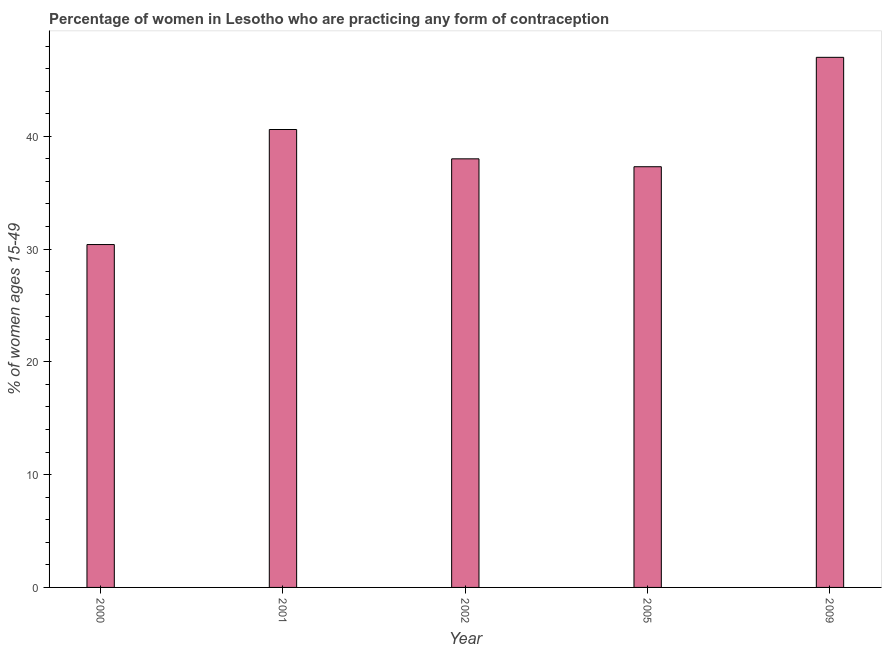What is the title of the graph?
Provide a succinct answer. Percentage of women in Lesotho who are practicing any form of contraception. What is the label or title of the X-axis?
Provide a short and direct response. Year. What is the label or title of the Y-axis?
Provide a short and direct response. % of women ages 15-49. What is the contraceptive prevalence in 2005?
Your response must be concise. 37.3. Across all years, what is the minimum contraceptive prevalence?
Offer a very short reply. 30.4. In which year was the contraceptive prevalence minimum?
Make the answer very short. 2000. What is the sum of the contraceptive prevalence?
Make the answer very short. 193.3. What is the difference between the contraceptive prevalence in 2002 and 2005?
Your answer should be very brief. 0.7. What is the average contraceptive prevalence per year?
Ensure brevity in your answer.  38.66. What is the median contraceptive prevalence?
Offer a terse response. 38. What is the ratio of the contraceptive prevalence in 2002 to that in 2009?
Make the answer very short. 0.81. What is the difference between the highest and the lowest contraceptive prevalence?
Your answer should be compact. 16.6. What is the % of women ages 15-49 in 2000?
Your answer should be compact. 30.4. What is the % of women ages 15-49 in 2001?
Offer a very short reply. 40.6. What is the % of women ages 15-49 of 2002?
Offer a terse response. 38. What is the % of women ages 15-49 of 2005?
Your answer should be very brief. 37.3. What is the % of women ages 15-49 in 2009?
Provide a short and direct response. 47. What is the difference between the % of women ages 15-49 in 2000 and 2001?
Provide a short and direct response. -10.2. What is the difference between the % of women ages 15-49 in 2000 and 2009?
Ensure brevity in your answer.  -16.6. What is the difference between the % of women ages 15-49 in 2001 and 2002?
Your answer should be compact. 2.6. What is the difference between the % of women ages 15-49 in 2001 and 2009?
Ensure brevity in your answer.  -6.4. What is the difference between the % of women ages 15-49 in 2002 and 2005?
Keep it short and to the point. 0.7. What is the difference between the % of women ages 15-49 in 2005 and 2009?
Provide a short and direct response. -9.7. What is the ratio of the % of women ages 15-49 in 2000 to that in 2001?
Give a very brief answer. 0.75. What is the ratio of the % of women ages 15-49 in 2000 to that in 2002?
Ensure brevity in your answer.  0.8. What is the ratio of the % of women ages 15-49 in 2000 to that in 2005?
Provide a succinct answer. 0.81. What is the ratio of the % of women ages 15-49 in 2000 to that in 2009?
Keep it short and to the point. 0.65. What is the ratio of the % of women ages 15-49 in 2001 to that in 2002?
Offer a very short reply. 1.07. What is the ratio of the % of women ages 15-49 in 2001 to that in 2005?
Your answer should be very brief. 1.09. What is the ratio of the % of women ages 15-49 in 2001 to that in 2009?
Make the answer very short. 0.86. What is the ratio of the % of women ages 15-49 in 2002 to that in 2005?
Offer a terse response. 1.02. What is the ratio of the % of women ages 15-49 in 2002 to that in 2009?
Your answer should be very brief. 0.81. What is the ratio of the % of women ages 15-49 in 2005 to that in 2009?
Give a very brief answer. 0.79. 